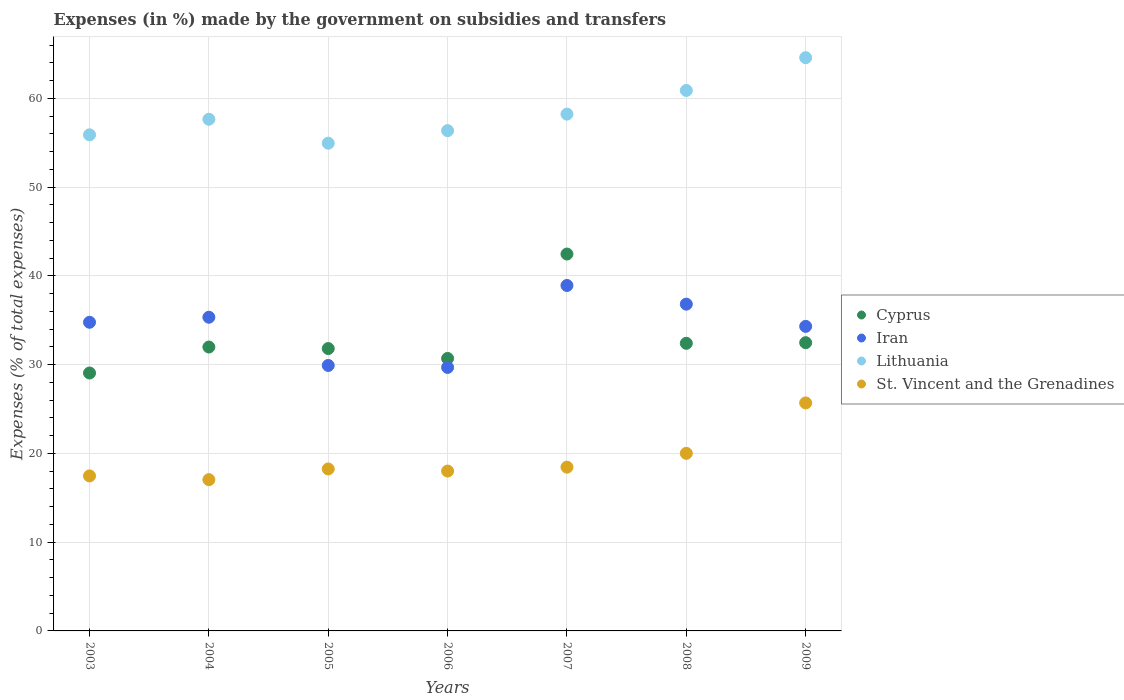What is the percentage of expenses made by the government on subsidies and transfers in Lithuania in 2004?
Your answer should be very brief. 57.65. Across all years, what is the maximum percentage of expenses made by the government on subsidies and transfers in St. Vincent and the Grenadines?
Offer a very short reply. 25.69. Across all years, what is the minimum percentage of expenses made by the government on subsidies and transfers in Lithuania?
Provide a short and direct response. 54.96. In which year was the percentage of expenses made by the government on subsidies and transfers in Lithuania maximum?
Your answer should be very brief. 2009. What is the total percentage of expenses made by the government on subsidies and transfers in St. Vincent and the Grenadines in the graph?
Your answer should be very brief. 134.93. What is the difference between the percentage of expenses made by the government on subsidies and transfers in Iran in 2006 and that in 2008?
Provide a succinct answer. -7.13. What is the difference between the percentage of expenses made by the government on subsidies and transfers in Iran in 2003 and the percentage of expenses made by the government on subsidies and transfers in St. Vincent and the Grenadines in 2009?
Ensure brevity in your answer.  9.09. What is the average percentage of expenses made by the government on subsidies and transfers in Iran per year?
Offer a very short reply. 34.26. In the year 2006, what is the difference between the percentage of expenses made by the government on subsidies and transfers in Iran and percentage of expenses made by the government on subsidies and transfers in St. Vincent and the Grenadines?
Give a very brief answer. 11.68. What is the ratio of the percentage of expenses made by the government on subsidies and transfers in St. Vincent and the Grenadines in 2006 to that in 2009?
Make the answer very short. 0.7. Is the percentage of expenses made by the government on subsidies and transfers in St. Vincent and the Grenadines in 2007 less than that in 2008?
Your answer should be compact. Yes. Is the difference between the percentage of expenses made by the government on subsidies and transfers in Iran in 2004 and 2007 greater than the difference between the percentage of expenses made by the government on subsidies and transfers in St. Vincent and the Grenadines in 2004 and 2007?
Offer a very short reply. No. What is the difference between the highest and the second highest percentage of expenses made by the government on subsidies and transfers in St. Vincent and the Grenadines?
Keep it short and to the point. 5.68. What is the difference between the highest and the lowest percentage of expenses made by the government on subsidies and transfers in Lithuania?
Offer a terse response. 9.64. Is it the case that in every year, the sum of the percentage of expenses made by the government on subsidies and transfers in St. Vincent and the Grenadines and percentage of expenses made by the government on subsidies and transfers in Cyprus  is greater than the sum of percentage of expenses made by the government on subsidies and transfers in Lithuania and percentage of expenses made by the government on subsidies and transfers in Iran?
Offer a very short reply. Yes. Is the percentage of expenses made by the government on subsidies and transfers in Lithuania strictly greater than the percentage of expenses made by the government on subsidies and transfers in Iran over the years?
Your answer should be compact. Yes. Are the values on the major ticks of Y-axis written in scientific E-notation?
Make the answer very short. No. Does the graph contain grids?
Offer a terse response. Yes. How are the legend labels stacked?
Your answer should be very brief. Vertical. What is the title of the graph?
Your answer should be very brief. Expenses (in %) made by the government on subsidies and transfers. What is the label or title of the Y-axis?
Give a very brief answer. Expenses (% of total expenses). What is the Expenses (% of total expenses) of Cyprus in 2003?
Offer a terse response. 29.06. What is the Expenses (% of total expenses) in Iran in 2003?
Offer a terse response. 34.78. What is the Expenses (% of total expenses) of Lithuania in 2003?
Make the answer very short. 55.9. What is the Expenses (% of total expenses) of St. Vincent and the Grenadines in 2003?
Make the answer very short. 17.47. What is the Expenses (% of total expenses) in Cyprus in 2004?
Your response must be concise. 31.99. What is the Expenses (% of total expenses) in Iran in 2004?
Offer a terse response. 35.34. What is the Expenses (% of total expenses) of Lithuania in 2004?
Your response must be concise. 57.65. What is the Expenses (% of total expenses) of St. Vincent and the Grenadines in 2004?
Give a very brief answer. 17.04. What is the Expenses (% of total expenses) in Cyprus in 2005?
Offer a terse response. 31.82. What is the Expenses (% of total expenses) in Iran in 2005?
Your answer should be compact. 29.91. What is the Expenses (% of total expenses) of Lithuania in 2005?
Make the answer very short. 54.96. What is the Expenses (% of total expenses) in St. Vincent and the Grenadines in 2005?
Your response must be concise. 18.25. What is the Expenses (% of total expenses) of Cyprus in 2006?
Provide a short and direct response. 30.7. What is the Expenses (% of total expenses) in Iran in 2006?
Provide a short and direct response. 29.69. What is the Expenses (% of total expenses) of Lithuania in 2006?
Offer a very short reply. 56.37. What is the Expenses (% of total expenses) in St. Vincent and the Grenadines in 2006?
Your answer should be compact. 18.01. What is the Expenses (% of total expenses) of Cyprus in 2007?
Offer a very short reply. 42.47. What is the Expenses (% of total expenses) in Iran in 2007?
Your answer should be very brief. 38.93. What is the Expenses (% of total expenses) of Lithuania in 2007?
Your response must be concise. 58.23. What is the Expenses (% of total expenses) of St. Vincent and the Grenadines in 2007?
Offer a very short reply. 18.45. What is the Expenses (% of total expenses) of Cyprus in 2008?
Ensure brevity in your answer.  32.41. What is the Expenses (% of total expenses) of Iran in 2008?
Provide a succinct answer. 36.82. What is the Expenses (% of total expenses) of Lithuania in 2008?
Ensure brevity in your answer.  60.9. What is the Expenses (% of total expenses) of St. Vincent and the Grenadines in 2008?
Provide a short and direct response. 20.01. What is the Expenses (% of total expenses) in Cyprus in 2009?
Offer a terse response. 32.48. What is the Expenses (% of total expenses) in Iran in 2009?
Your answer should be compact. 34.32. What is the Expenses (% of total expenses) in Lithuania in 2009?
Provide a succinct answer. 64.59. What is the Expenses (% of total expenses) of St. Vincent and the Grenadines in 2009?
Your answer should be compact. 25.69. Across all years, what is the maximum Expenses (% of total expenses) in Cyprus?
Give a very brief answer. 42.47. Across all years, what is the maximum Expenses (% of total expenses) in Iran?
Keep it short and to the point. 38.93. Across all years, what is the maximum Expenses (% of total expenses) in Lithuania?
Provide a short and direct response. 64.59. Across all years, what is the maximum Expenses (% of total expenses) of St. Vincent and the Grenadines?
Ensure brevity in your answer.  25.69. Across all years, what is the minimum Expenses (% of total expenses) of Cyprus?
Your answer should be compact. 29.06. Across all years, what is the minimum Expenses (% of total expenses) in Iran?
Provide a short and direct response. 29.69. Across all years, what is the minimum Expenses (% of total expenses) in Lithuania?
Your response must be concise. 54.96. Across all years, what is the minimum Expenses (% of total expenses) of St. Vincent and the Grenadines?
Your answer should be very brief. 17.04. What is the total Expenses (% of total expenses) of Cyprus in the graph?
Provide a succinct answer. 230.93. What is the total Expenses (% of total expenses) of Iran in the graph?
Ensure brevity in your answer.  239.79. What is the total Expenses (% of total expenses) in Lithuania in the graph?
Make the answer very short. 408.61. What is the total Expenses (% of total expenses) of St. Vincent and the Grenadines in the graph?
Make the answer very short. 134.93. What is the difference between the Expenses (% of total expenses) of Cyprus in 2003 and that in 2004?
Keep it short and to the point. -2.93. What is the difference between the Expenses (% of total expenses) in Iran in 2003 and that in 2004?
Offer a very short reply. -0.57. What is the difference between the Expenses (% of total expenses) of Lithuania in 2003 and that in 2004?
Offer a terse response. -1.75. What is the difference between the Expenses (% of total expenses) in St. Vincent and the Grenadines in 2003 and that in 2004?
Ensure brevity in your answer.  0.43. What is the difference between the Expenses (% of total expenses) of Cyprus in 2003 and that in 2005?
Offer a terse response. -2.75. What is the difference between the Expenses (% of total expenses) of Iran in 2003 and that in 2005?
Your answer should be compact. 4.87. What is the difference between the Expenses (% of total expenses) in Lithuania in 2003 and that in 2005?
Provide a succinct answer. 0.94. What is the difference between the Expenses (% of total expenses) in St. Vincent and the Grenadines in 2003 and that in 2005?
Your response must be concise. -0.78. What is the difference between the Expenses (% of total expenses) in Cyprus in 2003 and that in 2006?
Make the answer very short. -1.64. What is the difference between the Expenses (% of total expenses) of Iran in 2003 and that in 2006?
Offer a terse response. 5.09. What is the difference between the Expenses (% of total expenses) in Lithuania in 2003 and that in 2006?
Give a very brief answer. -0.47. What is the difference between the Expenses (% of total expenses) of St. Vincent and the Grenadines in 2003 and that in 2006?
Offer a terse response. -0.55. What is the difference between the Expenses (% of total expenses) in Cyprus in 2003 and that in 2007?
Your answer should be compact. -13.41. What is the difference between the Expenses (% of total expenses) of Iran in 2003 and that in 2007?
Offer a terse response. -4.15. What is the difference between the Expenses (% of total expenses) of Lithuania in 2003 and that in 2007?
Ensure brevity in your answer.  -2.33. What is the difference between the Expenses (% of total expenses) in St. Vincent and the Grenadines in 2003 and that in 2007?
Offer a terse response. -0.99. What is the difference between the Expenses (% of total expenses) of Cyprus in 2003 and that in 2008?
Make the answer very short. -3.35. What is the difference between the Expenses (% of total expenses) of Iran in 2003 and that in 2008?
Provide a succinct answer. -2.04. What is the difference between the Expenses (% of total expenses) in Lithuania in 2003 and that in 2008?
Your answer should be compact. -5. What is the difference between the Expenses (% of total expenses) in St. Vincent and the Grenadines in 2003 and that in 2008?
Keep it short and to the point. -2.54. What is the difference between the Expenses (% of total expenses) of Cyprus in 2003 and that in 2009?
Your answer should be compact. -3.42. What is the difference between the Expenses (% of total expenses) of Iran in 2003 and that in 2009?
Provide a succinct answer. 0.46. What is the difference between the Expenses (% of total expenses) in Lithuania in 2003 and that in 2009?
Your answer should be compact. -8.69. What is the difference between the Expenses (% of total expenses) in St. Vincent and the Grenadines in 2003 and that in 2009?
Your answer should be compact. -8.22. What is the difference between the Expenses (% of total expenses) in Cyprus in 2004 and that in 2005?
Give a very brief answer. 0.17. What is the difference between the Expenses (% of total expenses) in Iran in 2004 and that in 2005?
Offer a very short reply. 5.43. What is the difference between the Expenses (% of total expenses) of Lithuania in 2004 and that in 2005?
Offer a terse response. 2.7. What is the difference between the Expenses (% of total expenses) in St. Vincent and the Grenadines in 2004 and that in 2005?
Offer a terse response. -1.21. What is the difference between the Expenses (% of total expenses) of Cyprus in 2004 and that in 2006?
Keep it short and to the point. 1.29. What is the difference between the Expenses (% of total expenses) in Iran in 2004 and that in 2006?
Ensure brevity in your answer.  5.65. What is the difference between the Expenses (% of total expenses) of Lithuania in 2004 and that in 2006?
Your answer should be very brief. 1.28. What is the difference between the Expenses (% of total expenses) in St. Vincent and the Grenadines in 2004 and that in 2006?
Provide a succinct answer. -0.97. What is the difference between the Expenses (% of total expenses) in Cyprus in 2004 and that in 2007?
Provide a succinct answer. -10.48. What is the difference between the Expenses (% of total expenses) in Iran in 2004 and that in 2007?
Keep it short and to the point. -3.58. What is the difference between the Expenses (% of total expenses) in Lithuania in 2004 and that in 2007?
Offer a very short reply. -0.58. What is the difference between the Expenses (% of total expenses) in St. Vincent and the Grenadines in 2004 and that in 2007?
Offer a terse response. -1.41. What is the difference between the Expenses (% of total expenses) of Cyprus in 2004 and that in 2008?
Offer a very short reply. -0.42. What is the difference between the Expenses (% of total expenses) of Iran in 2004 and that in 2008?
Give a very brief answer. -1.48. What is the difference between the Expenses (% of total expenses) of Lithuania in 2004 and that in 2008?
Offer a very short reply. -3.25. What is the difference between the Expenses (% of total expenses) of St. Vincent and the Grenadines in 2004 and that in 2008?
Offer a terse response. -2.97. What is the difference between the Expenses (% of total expenses) in Cyprus in 2004 and that in 2009?
Keep it short and to the point. -0.49. What is the difference between the Expenses (% of total expenses) of Iran in 2004 and that in 2009?
Offer a terse response. 1.03. What is the difference between the Expenses (% of total expenses) of Lithuania in 2004 and that in 2009?
Offer a terse response. -6.94. What is the difference between the Expenses (% of total expenses) in St. Vincent and the Grenadines in 2004 and that in 2009?
Your answer should be very brief. -8.65. What is the difference between the Expenses (% of total expenses) of Cyprus in 2005 and that in 2006?
Ensure brevity in your answer.  1.11. What is the difference between the Expenses (% of total expenses) in Iran in 2005 and that in 2006?
Provide a short and direct response. 0.22. What is the difference between the Expenses (% of total expenses) in Lithuania in 2005 and that in 2006?
Provide a succinct answer. -1.42. What is the difference between the Expenses (% of total expenses) of St. Vincent and the Grenadines in 2005 and that in 2006?
Your answer should be very brief. 0.24. What is the difference between the Expenses (% of total expenses) in Cyprus in 2005 and that in 2007?
Provide a succinct answer. -10.65. What is the difference between the Expenses (% of total expenses) in Iran in 2005 and that in 2007?
Make the answer very short. -9.01. What is the difference between the Expenses (% of total expenses) in Lithuania in 2005 and that in 2007?
Give a very brief answer. -3.28. What is the difference between the Expenses (% of total expenses) of St. Vincent and the Grenadines in 2005 and that in 2007?
Your answer should be very brief. -0.2. What is the difference between the Expenses (% of total expenses) of Cyprus in 2005 and that in 2008?
Offer a terse response. -0.59. What is the difference between the Expenses (% of total expenses) of Iran in 2005 and that in 2008?
Provide a succinct answer. -6.91. What is the difference between the Expenses (% of total expenses) in Lithuania in 2005 and that in 2008?
Your answer should be compact. -5.94. What is the difference between the Expenses (% of total expenses) in St. Vincent and the Grenadines in 2005 and that in 2008?
Give a very brief answer. -1.76. What is the difference between the Expenses (% of total expenses) of Cyprus in 2005 and that in 2009?
Offer a very short reply. -0.66. What is the difference between the Expenses (% of total expenses) in Iran in 2005 and that in 2009?
Your response must be concise. -4.4. What is the difference between the Expenses (% of total expenses) of Lithuania in 2005 and that in 2009?
Provide a short and direct response. -9.64. What is the difference between the Expenses (% of total expenses) of St. Vincent and the Grenadines in 2005 and that in 2009?
Provide a short and direct response. -7.44. What is the difference between the Expenses (% of total expenses) in Cyprus in 2006 and that in 2007?
Ensure brevity in your answer.  -11.76. What is the difference between the Expenses (% of total expenses) in Iran in 2006 and that in 2007?
Offer a very short reply. -9.23. What is the difference between the Expenses (% of total expenses) of Lithuania in 2006 and that in 2007?
Your answer should be very brief. -1.86. What is the difference between the Expenses (% of total expenses) in St. Vincent and the Grenadines in 2006 and that in 2007?
Your response must be concise. -0.44. What is the difference between the Expenses (% of total expenses) of Cyprus in 2006 and that in 2008?
Your answer should be very brief. -1.7. What is the difference between the Expenses (% of total expenses) in Iran in 2006 and that in 2008?
Your answer should be very brief. -7.13. What is the difference between the Expenses (% of total expenses) in Lithuania in 2006 and that in 2008?
Offer a very short reply. -4.53. What is the difference between the Expenses (% of total expenses) of St. Vincent and the Grenadines in 2006 and that in 2008?
Your answer should be compact. -2. What is the difference between the Expenses (% of total expenses) of Cyprus in 2006 and that in 2009?
Provide a short and direct response. -1.78. What is the difference between the Expenses (% of total expenses) of Iran in 2006 and that in 2009?
Give a very brief answer. -4.62. What is the difference between the Expenses (% of total expenses) in Lithuania in 2006 and that in 2009?
Provide a succinct answer. -8.22. What is the difference between the Expenses (% of total expenses) of St. Vincent and the Grenadines in 2006 and that in 2009?
Provide a succinct answer. -7.68. What is the difference between the Expenses (% of total expenses) of Cyprus in 2007 and that in 2008?
Your answer should be compact. 10.06. What is the difference between the Expenses (% of total expenses) in Iran in 2007 and that in 2008?
Provide a short and direct response. 2.1. What is the difference between the Expenses (% of total expenses) of Lithuania in 2007 and that in 2008?
Give a very brief answer. -2.67. What is the difference between the Expenses (% of total expenses) of St. Vincent and the Grenadines in 2007 and that in 2008?
Your answer should be very brief. -1.56. What is the difference between the Expenses (% of total expenses) in Cyprus in 2007 and that in 2009?
Your response must be concise. 9.99. What is the difference between the Expenses (% of total expenses) in Iran in 2007 and that in 2009?
Make the answer very short. 4.61. What is the difference between the Expenses (% of total expenses) in Lithuania in 2007 and that in 2009?
Your answer should be very brief. -6.36. What is the difference between the Expenses (% of total expenses) in St. Vincent and the Grenadines in 2007 and that in 2009?
Your answer should be very brief. -7.24. What is the difference between the Expenses (% of total expenses) in Cyprus in 2008 and that in 2009?
Your answer should be compact. -0.07. What is the difference between the Expenses (% of total expenses) of Iran in 2008 and that in 2009?
Give a very brief answer. 2.5. What is the difference between the Expenses (% of total expenses) of Lithuania in 2008 and that in 2009?
Provide a short and direct response. -3.69. What is the difference between the Expenses (% of total expenses) in St. Vincent and the Grenadines in 2008 and that in 2009?
Your answer should be compact. -5.68. What is the difference between the Expenses (% of total expenses) of Cyprus in 2003 and the Expenses (% of total expenses) of Iran in 2004?
Provide a short and direct response. -6.28. What is the difference between the Expenses (% of total expenses) of Cyprus in 2003 and the Expenses (% of total expenses) of Lithuania in 2004?
Your answer should be compact. -28.59. What is the difference between the Expenses (% of total expenses) of Cyprus in 2003 and the Expenses (% of total expenses) of St. Vincent and the Grenadines in 2004?
Ensure brevity in your answer.  12.02. What is the difference between the Expenses (% of total expenses) in Iran in 2003 and the Expenses (% of total expenses) in Lithuania in 2004?
Provide a succinct answer. -22.88. What is the difference between the Expenses (% of total expenses) in Iran in 2003 and the Expenses (% of total expenses) in St. Vincent and the Grenadines in 2004?
Your answer should be compact. 17.74. What is the difference between the Expenses (% of total expenses) in Lithuania in 2003 and the Expenses (% of total expenses) in St. Vincent and the Grenadines in 2004?
Ensure brevity in your answer.  38.86. What is the difference between the Expenses (% of total expenses) in Cyprus in 2003 and the Expenses (% of total expenses) in Iran in 2005?
Offer a terse response. -0.85. What is the difference between the Expenses (% of total expenses) of Cyprus in 2003 and the Expenses (% of total expenses) of Lithuania in 2005?
Ensure brevity in your answer.  -25.89. What is the difference between the Expenses (% of total expenses) in Cyprus in 2003 and the Expenses (% of total expenses) in St. Vincent and the Grenadines in 2005?
Ensure brevity in your answer.  10.81. What is the difference between the Expenses (% of total expenses) of Iran in 2003 and the Expenses (% of total expenses) of Lithuania in 2005?
Offer a terse response. -20.18. What is the difference between the Expenses (% of total expenses) of Iran in 2003 and the Expenses (% of total expenses) of St. Vincent and the Grenadines in 2005?
Your response must be concise. 16.53. What is the difference between the Expenses (% of total expenses) in Lithuania in 2003 and the Expenses (% of total expenses) in St. Vincent and the Grenadines in 2005?
Offer a terse response. 37.65. What is the difference between the Expenses (% of total expenses) in Cyprus in 2003 and the Expenses (% of total expenses) in Iran in 2006?
Offer a very short reply. -0.63. What is the difference between the Expenses (% of total expenses) of Cyprus in 2003 and the Expenses (% of total expenses) of Lithuania in 2006?
Make the answer very short. -27.31. What is the difference between the Expenses (% of total expenses) in Cyprus in 2003 and the Expenses (% of total expenses) in St. Vincent and the Grenadines in 2006?
Make the answer very short. 11.05. What is the difference between the Expenses (% of total expenses) in Iran in 2003 and the Expenses (% of total expenses) in Lithuania in 2006?
Ensure brevity in your answer.  -21.59. What is the difference between the Expenses (% of total expenses) in Iran in 2003 and the Expenses (% of total expenses) in St. Vincent and the Grenadines in 2006?
Give a very brief answer. 16.76. What is the difference between the Expenses (% of total expenses) of Lithuania in 2003 and the Expenses (% of total expenses) of St. Vincent and the Grenadines in 2006?
Offer a very short reply. 37.89. What is the difference between the Expenses (% of total expenses) in Cyprus in 2003 and the Expenses (% of total expenses) in Iran in 2007?
Provide a short and direct response. -9.86. What is the difference between the Expenses (% of total expenses) in Cyprus in 2003 and the Expenses (% of total expenses) in Lithuania in 2007?
Your answer should be compact. -29.17. What is the difference between the Expenses (% of total expenses) of Cyprus in 2003 and the Expenses (% of total expenses) of St. Vincent and the Grenadines in 2007?
Your answer should be compact. 10.61. What is the difference between the Expenses (% of total expenses) of Iran in 2003 and the Expenses (% of total expenses) of Lithuania in 2007?
Provide a succinct answer. -23.46. What is the difference between the Expenses (% of total expenses) of Iran in 2003 and the Expenses (% of total expenses) of St. Vincent and the Grenadines in 2007?
Keep it short and to the point. 16.33. What is the difference between the Expenses (% of total expenses) of Lithuania in 2003 and the Expenses (% of total expenses) of St. Vincent and the Grenadines in 2007?
Your answer should be compact. 37.45. What is the difference between the Expenses (% of total expenses) in Cyprus in 2003 and the Expenses (% of total expenses) in Iran in 2008?
Keep it short and to the point. -7.76. What is the difference between the Expenses (% of total expenses) of Cyprus in 2003 and the Expenses (% of total expenses) of Lithuania in 2008?
Offer a very short reply. -31.84. What is the difference between the Expenses (% of total expenses) in Cyprus in 2003 and the Expenses (% of total expenses) in St. Vincent and the Grenadines in 2008?
Ensure brevity in your answer.  9.05. What is the difference between the Expenses (% of total expenses) in Iran in 2003 and the Expenses (% of total expenses) in Lithuania in 2008?
Offer a terse response. -26.12. What is the difference between the Expenses (% of total expenses) of Iran in 2003 and the Expenses (% of total expenses) of St. Vincent and the Grenadines in 2008?
Give a very brief answer. 14.77. What is the difference between the Expenses (% of total expenses) in Lithuania in 2003 and the Expenses (% of total expenses) in St. Vincent and the Grenadines in 2008?
Your response must be concise. 35.89. What is the difference between the Expenses (% of total expenses) in Cyprus in 2003 and the Expenses (% of total expenses) in Iran in 2009?
Offer a terse response. -5.25. What is the difference between the Expenses (% of total expenses) in Cyprus in 2003 and the Expenses (% of total expenses) in Lithuania in 2009?
Ensure brevity in your answer.  -35.53. What is the difference between the Expenses (% of total expenses) in Cyprus in 2003 and the Expenses (% of total expenses) in St. Vincent and the Grenadines in 2009?
Give a very brief answer. 3.37. What is the difference between the Expenses (% of total expenses) in Iran in 2003 and the Expenses (% of total expenses) in Lithuania in 2009?
Your response must be concise. -29.82. What is the difference between the Expenses (% of total expenses) in Iran in 2003 and the Expenses (% of total expenses) in St. Vincent and the Grenadines in 2009?
Your response must be concise. 9.09. What is the difference between the Expenses (% of total expenses) of Lithuania in 2003 and the Expenses (% of total expenses) of St. Vincent and the Grenadines in 2009?
Your response must be concise. 30.21. What is the difference between the Expenses (% of total expenses) of Cyprus in 2004 and the Expenses (% of total expenses) of Iran in 2005?
Offer a very short reply. 2.08. What is the difference between the Expenses (% of total expenses) in Cyprus in 2004 and the Expenses (% of total expenses) in Lithuania in 2005?
Your answer should be compact. -22.97. What is the difference between the Expenses (% of total expenses) of Cyprus in 2004 and the Expenses (% of total expenses) of St. Vincent and the Grenadines in 2005?
Offer a terse response. 13.74. What is the difference between the Expenses (% of total expenses) in Iran in 2004 and the Expenses (% of total expenses) in Lithuania in 2005?
Your response must be concise. -19.61. What is the difference between the Expenses (% of total expenses) of Iran in 2004 and the Expenses (% of total expenses) of St. Vincent and the Grenadines in 2005?
Your response must be concise. 17.09. What is the difference between the Expenses (% of total expenses) in Lithuania in 2004 and the Expenses (% of total expenses) in St. Vincent and the Grenadines in 2005?
Give a very brief answer. 39.4. What is the difference between the Expenses (% of total expenses) in Cyprus in 2004 and the Expenses (% of total expenses) in Iran in 2006?
Offer a terse response. 2.3. What is the difference between the Expenses (% of total expenses) in Cyprus in 2004 and the Expenses (% of total expenses) in Lithuania in 2006?
Make the answer very short. -24.38. What is the difference between the Expenses (% of total expenses) in Cyprus in 2004 and the Expenses (% of total expenses) in St. Vincent and the Grenadines in 2006?
Provide a succinct answer. 13.98. What is the difference between the Expenses (% of total expenses) of Iran in 2004 and the Expenses (% of total expenses) of Lithuania in 2006?
Your response must be concise. -21.03. What is the difference between the Expenses (% of total expenses) in Iran in 2004 and the Expenses (% of total expenses) in St. Vincent and the Grenadines in 2006?
Your answer should be compact. 17.33. What is the difference between the Expenses (% of total expenses) of Lithuania in 2004 and the Expenses (% of total expenses) of St. Vincent and the Grenadines in 2006?
Offer a terse response. 39.64. What is the difference between the Expenses (% of total expenses) in Cyprus in 2004 and the Expenses (% of total expenses) in Iran in 2007?
Provide a short and direct response. -6.94. What is the difference between the Expenses (% of total expenses) in Cyprus in 2004 and the Expenses (% of total expenses) in Lithuania in 2007?
Your answer should be very brief. -26.24. What is the difference between the Expenses (% of total expenses) of Cyprus in 2004 and the Expenses (% of total expenses) of St. Vincent and the Grenadines in 2007?
Ensure brevity in your answer.  13.54. What is the difference between the Expenses (% of total expenses) of Iran in 2004 and the Expenses (% of total expenses) of Lithuania in 2007?
Ensure brevity in your answer.  -22.89. What is the difference between the Expenses (% of total expenses) in Iran in 2004 and the Expenses (% of total expenses) in St. Vincent and the Grenadines in 2007?
Make the answer very short. 16.89. What is the difference between the Expenses (% of total expenses) of Lithuania in 2004 and the Expenses (% of total expenses) of St. Vincent and the Grenadines in 2007?
Offer a very short reply. 39.2. What is the difference between the Expenses (% of total expenses) in Cyprus in 2004 and the Expenses (% of total expenses) in Iran in 2008?
Offer a very short reply. -4.83. What is the difference between the Expenses (% of total expenses) in Cyprus in 2004 and the Expenses (% of total expenses) in Lithuania in 2008?
Ensure brevity in your answer.  -28.91. What is the difference between the Expenses (% of total expenses) of Cyprus in 2004 and the Expenses (% of total expenses) of St. Vincent and the Grenadines in 2008?
Your answer should be very brief. 11.98. What is the difference between the Expenses (% of total expenses) in Iran in 2004 and the Expenses (% of total expenses) in Lithuania in 2008?
Your response must be concise. -25.55. What is the difference between the Expenses (% of total expenses) in Iran in 2004 and the Expenses (% of total expenses) in St. Vincent and the Grenadines in 2008?
Give a very brief answer. 15.34. What is the difference between the Expenses (% of total expenses) of Lithuania in 2004 and the Expenses (% of total expenses) of St. Vincent and the Grenadines in 2008?
Provide a short and direct response. 37.65. What is the difference between the Expenses (% of total expenses) in Cyprus in 2004 and the Expenses (% of total expenses) in Iran in 2009?
Provide a succinct answer. -2.33. What is the difference between the Expenses (% of total expenses) in Cyprus in 2004 and the Expenses (% of total expenses) in Lithuania in 2009?
Offer a very short reply. -32.6. What is the difference between the Expenses (% of total expenses) of Cyprus in 2004 and the Expenses (% of total expenses) of St. Vincent and the Grenadines in 2009?
Make the answer very short. 6.3. What is the difference between the Expenses (% of total expenses) in Iran in 2004 and the Expenses (% of total expenses) in Lithuania in 2009?
Offer a very short reply. -29.25. What is the difference between the Expenses (% of total expenses) of Iran in 2004 and the Expenses (% of total expenses) of St. Vincent and the Grenadines in 2009?
Ensure brevity in your answer.  9.65. What is the difference between the Expenses (% of total expenses) of Lithuania in 2004 and the Expenses (% of total expenses) of St. Vincent and the Grenadines in 2009?
Offer a very short reply. 31.96. What is the difference between the Expenses (% of total expenses) of Cyprus in 2005 and the Expenses (% of total expenses) of Iran in 2006?
Provide a short and direct response. 2.12. What is the difference between the Expenses (% of total expenses) of Cyprus in 2005 and the Expenses (% of total expenses) of Lithuania in 2006?
Your response must be concise. -24.55. What is the difference between the Expenses (% of total expenses) in Cyprus in 2005 and the Expenses (% of total expenses) in St. Vincent and the Grenadines in 2006?
Keep it short and to the point. 13.8. What is the difference between the Expenses (% of total expenses) in Iran in 2005 and the Expenses (% of total expenses) in Lithuania in 2006?
Offer a very short reply. -26.46. What is the difference between the Expenses (% of total expenses) of Iran in 2005 and the Expenses (% of total expenses) of St. Vincent and the Grenadines in 2006?
Provide a succinct answer. 11.9. What is the difference between the Expenses (% of total expenses) in Lithuania in 2005 and the Expenses (% of total expenses) in St. Vincent and the Grenadines in 2006?
Give a very brief answer. 36.94. What is the difference between the Expenses (% of total expenses) of Cyprus in 2005 and the Expenses (% of total expenses) of Iran in 2007?
Offer a very short reply. -7.11. What is the difference between the Expenses (% of total expenses) in Cyprus in 2005 and the Expenses (% of total expenses) in Lithuania in 2007?
Provide a short and direct response. -26.42. What is the difference between the Expenses (% of total expenses) of Cyprus in 2005 and the Expenses (% of total expenses) of St. Vincent and the Grenadines in 2007?
Make the answer very short. 13.36. What is the difference between the Expenses (% of total expenses) in Iran in 2005 and the Expenses (% of total expenses) in Lithuania in 2007?
Provide a succinct answer. -28.32. What is the difference between the Expenses (% of total expenses) in Iran in 2005 and the Expenses (% of total expenses) in St. Vincent and the Grenadines in 2007?
Your response must be concise. 11.46. What is the difference between the Expenses (% of total expenses) in Lithuania in 2005 and the Expenses (% of total expenses) in St. Vincent and the Grenadines in 2007?
Offer a very short reply. 36.5. What is the difference between the Expenses (% of total expenses) of Cyprus in 2005 and the Expenses (% of total expenses) of Iran in 2008?
Your answer should be compact. -5. What is the difference between the Expenses (% of total expenses) of Cyprus in 2005 and the Expenses (% of total expenses) of Lithuania in 2008?
Offer a very short reply. -29.08. What is the difference between the Expenses (% of total expenses) in Cyprus in 2005 and the Expenses (% of total expenses) in St. Vincent and the Grenadines in 2008?
Make the answer very short. 11.81. What is the difference between the Expenses (% of total expenses) in Iran in 2005 and the Expenses (% of total expenses) in Lithuania in 2008?
Offer a very short reply. -30.99. What is the difference between the Expenses (% of total expenses) of Iran in 2005 and the Expenses (% of total expenses) of St. Vincent and the Grenadines in 2008?
Your answer should be very brief. 9.9. What is the difference between the Expenses (% of total expenses) in Lithuania in 2005 and the Expenses (% of total expenses) in St. Vincent and the Grenadines in 2008?
Your answer should be compact. 34.95. What is the difference between the Expenses (% of total expenses) of Cyprus in 2005 and the Expenses (% of total expenses) of Iran in 2009?
Provide a short and direct response. -2.5. What is the difference between the Expenses (% of total expenses) in Cyprus in 2005 and the Expenses (% of total expenses) in Lithuania in 2009?
Provide a succinct answer. -32.78. What is the difference between the Expenses (% of total expenses) in Cyprus in 2005 and the Expenses (% of total expenses) in St. Vincent and the Grenadines in 2009?
Make the answer very short. 6.13. What is the difference between the Expenses (% of total expenses) in Iran in 2005 and the Expenses (% of total expenses) in Lithuania in 2009?
Provide a succinct answer. -34.68. What is the difference between the Expenses (% of total expenses) in Iran in 2005 and the Expenses (% of total expenses) in St. Vincent and the Grenadines in 2009?
Provide a short and direct response. 4.22. What is the difference between the Expenses (% of total expenses) of Lithuania in 2005 and the Expenses (% of total expenses) of St. Vincent and the Grenadines in 2009?
Make the answer very short. 29.26. What is the difference between the Expenses (% of total expenses) in Cyprus in 2006 and the Expenses (% of total expenses) in Iran in 2007?
Provide a short and direct response. -8.22. What is the difference between the Expenses (% of total expenses) in Cyprus in 2006 and the Expenses (% of total expenses) in Lithuania in 2007?
Your response must be concise. -27.53. What is the difference between the Expenses (% of total expenses) of Cyprus in 2006 and the Expenses (% of total expenses) of St. Vincent and the Grenadines in 2007?
Give a very brief answer. 12.25. What is the difference between the Expenses (% of total expenses) of Iran in 2006 and the Expenses (% of total expenses) of Lithuania in 2007?
Ensure brevity in your answer.  -28.54. What is the difference between the Expenses (% of total expenses) of Iran in 2006 and the Expenses (% of total expenses) of St. Vincent and the Grenadines in 2007?
Provide a succinct answer. 11.24. What is the difference between the Expenses (% of total expenses) of Lithuania in 2006 and the Expenses (% of total expenses) of St. Vincent and the Grenadines in 2007?
Your response must be concise. 37.92. What is the difference between the Expenses (% of total expenses) of Cyprus in 2006 and the Expenses (% of total expenses) of Iran in 2008?
Keep it short and to the point. -6.12. What is the difference between the Expenses (% of total expenses) of Cyprus in 2006 and the Expenses (% of total expenses) of Lithuania in 2008?
Your response must be concise. -30.2. What is the difference between the Expenses (% of total expenses) of Cyprus in 2006 and the Expenses (% of total expenses) of St. Vincent and the Grenadines in 2008?
Keep it short and to the point. 10.7. What is the difference between the Expenses (% of total expenses) of Iran in 2006 and the Expenses (% of total expenses) of Lithuania in 2008?
Provide a short and direct response. -31.21. What is the difference between the Expenses (% of total expenses) of Iran in 2006 and the Expenses (% of total expenses) of St. Vincent and the Grenadines in 2008?
Make the answer very short. 9.68. What is the difference between the Expenses (% of total expenses) in Lithuania in 2006 and the Expenses (% of total expenses) in St. Vincent and the Grenadines in 2008?
Offer a terse response. 36.36. What is the difference between the Expenses (% of total expenses) in Cyprus in 2006 and the Expenses (% of total expenses) in Iran in 2009?
Offer a terse response. -3.61. What is the difference between the Expenses (% of total expenses) in Cyprus in 2006 and the Expenses (% of total expenses) in Lithuania in 2009?
Your answer should be compact. -33.89. What is the difference between the Expenses (% of total expenses) of Cyprus in 2006 and the Expenses (% of total expenses) of St. Vincent and the Grenadines in 2009?
Make the answer very short. 5.01. What is the difference between the Expenses (% of total expenses) in Iran in 2006 and the Expenses (% of total expenses) in Lithuania in 2009?
Offer a very short reply. -34.9. What is the difference between the Expenses (% of total expenses) of Iran in 2006 and the Expenses (% of total expenses) of St. Vincent and the Grenadines in 2009?
Offer a very short reply. 4. What is the difference between the Expenses (% of total expenses) in Lithuania in 2006 and the Expenses (% of total expenses) in St. Vincent and the Grenadines in 2009?
Your answer should be very brief. 30.68. What is the difference between the Expenses (% of total expenses) in Cyprus in 2007 and the Expenses (% of total expenses) in Iran in 2008?
Give a very brief answer. 5.65. What is the difference between the Expenses (% of total expenses) in Cyprus in 2007 and the Expenses (% of total expenses) in Lithuania in 2008?
Provide a short and direct response. -18.43. What is the difference between the Expenses (% of total expenses) in Cyprus in 2007 and the Expenses (% of total expenses) in St. Vincent and the Grenadines in 2008?
Give a very brief answer. 22.46. What is the difference between the Expenses (% of total expenses) of Iran in 2007 and the Expenses (% of total expenses) of Lithuania in 2008?
Make the answer very short. -21.97. What is the difference between the Expenses (% of total expenses) of Iran in 2007 and the Expenses (% of total expenses) of St. Vincent and the Grenadines in 2008?
Provide a succinct answer. 18.92. What is the difference between the Expenses (% of total expenses) of Lithuania in 2007 and the Expenses (% of total expenses) of St. Vincent and the Grenadines in 2008?
Give a very brief answer. 38.22. What is the difference between the Expenses (% of total expenses) of Cyprus in 2007 and the Expenses (% of total expenses) of Iran in 2009?
Offer a terse response. 8.15. What is the difference between the Expenses (% of total expenses) of Cyprus in 2007 and the Expenses (% of total expenses) of Lithuania in 2009?
Ensure brevity in your answer.  -22.13. What is the difference between the Expenses (% of total expenses) of Cyprus in 2007 and the Expenses (% of total expenses) of St. Vincent and the Grenadines in 2009?
Offer a very short reply. 16.78. What is the difference between the Expenses (% of total expenses) of Iran in 2007 and the Expenses (% of total expenses) of Lithuania in 2009?
Provide a succinct answer. -25.67. What is the difference between the Expenses (% of total expenses) in Iran in 2007 and the Expenses (% of total expenses) in St. Vincent and the Grenadines in 2009?
Your response must be concise. 13.23. What is the difference between the Expenses (% of total expenses) of Lithuania in 2007 and the Expenses (% of total expenses) of St. Vincent and the Grenadines in 2009?
Give a very brief answer. 32.54. What is the difference between the Expenses (% of total expenses) in Cyprus in 2008 and the Expenses (% of total expenses) in Iran in 2009?
Your response must be concise. -1.91. What is the difference between the Expenses (% of total expenses) of Cyprus in 2008 and the Expenses (% of total expenses) of Lithuania in 2009?
Offer a very short reply. -32.19. What is the difference between the Expenses (% of total expenses) in Cyprus in 2008 and the Expenses (% of total expenses) in St. Vincent and the Grenadines in 2009?
Make the answer very short. 6.72. What is the difference between the Expenses (% of total expenses) of Iran in 2008 and the Expenses (% of total expenses) of Lithuania in 2009?
Provide a succinct answer. -27.77. What is the difference between the Expenses (% of total expenses) of Iran in 2008 and the Expenses (% of total expenses) of St. Vincent and the Grenadines in 2009?
Provide a short and direct response. 11.13. What is the difference between the Expenses (% of total expenses) in Lithuania in 2008 and the Expenses (% of total expenses) in St. Vincent and the Grenadines in 2009?
Ensure brevity in your answer.  35.21. What is the average Expenses (% of total expenses) of Cyprus per year?
Offer a terse response. 32.99. What is the average Expenses (% of total expenses) in Iran per year?
Offer a very short reply. 34.26. What is the average Expenses (% of total expenses) of Lithuania per year?
Ensure brevity in your answer.  58.37. What is the average Expenses (% of total expenses) in St. Vincent and the Grenadines per year?
Keep it short and to the point. 19.28. In the year 2003, what is the difference between the Expenses (% of total expenses) in Cyprus and Expenses (% of total expenses) in Iran?
Keep it short and to the point. -5.72. In the year 2003, what is the difference between the Expenses (% of total expenses) in Cyprus and Expenses (% of total expenses) in Lithuania?
Your answer should be very brief. -26.84. In the year 2003, what is the difference between the Expenses (% of total expenses) of Cyprus and Expenses (% of total expenses) of St. Vincent and the Grenadines?
Your answer should be very brief. 11.59. In the year 2003, what is the difference between the Expenses (% of total expenses) of Iran and Expenses (% of total expenses) of Lithuania?
Give a very brief answer. -21.12. In the year 2003, what is the difference between the Expenses (% of total expenses) of Iran and Expenses (% of total expenses) of St. Vincent and the Grenadines?
Your answer should be compact. 17.31. In the year 2003, what is the difference between the Expenses (% of total expenses) of Lithuania and Expenses (% of total expenses) of St. Vincent and the Grenadines?
Provide a short and direct response. 38.43. In the year 2004, what is the difference between the Expenses (% of total expenses) of Cyprus and Expenses (% of total expenses) of Iran?
Make the answer very short. -3.35. In the year 2004, what is the difference between the Expenses (% of total expenses) in Cyprus and Expenses (% of total expenses) in Lithuania?
Your answer should be compact. -25.66. In the year 2004, what is the difference between the Expenses (% of total expenses) in Cyprus and Expenses (% of total expenses) in St. Vincent and the Grenadines?
Give a very brief answer. 14.95. In the year 2004, what is the difference between the Expenses (% of total expenses) of Iran and Expenses (% of total expenses) of Lithuania?
Offer a very short reply. -22.31. In the year 2004, what is the difference between the Expenses (% of total expenses) of Iran and Expenses (% of total expenses) of St. Vincent and the Grenadines?
Offer a terse response. 18.3. In the year 2004, what is the difference between the Expenses (% of total expenses) in Lithuania and Expenses (% of total expenses) in St. Vincent and the Grenadines?
Keep it short and to the point. 40.61. In the year 2005, what is the difference between the Expenses (% of total expenses) of Cyprus and Expenses (% of total expenses) of Iran?
Ensure brevity in your answer.  1.9. In the year 2005, what is the difference between the Expenses (% of total expenses) in Cyprus and Expenses (% of total expenses) in Lithuania?
Provide a short and direct response. -23.14. In the year 2005, what is the difference between the Expenses (% of total expenses) in Cyprus and Expenses (% of total expenses) in St. Vincent and the Grenadines?
Ensure brevity in your answer.  13.57. In the year 2005, what is the difference between the Expenses (% of total expenses) of Iran and Expenses (% of total expenses) of Lithuania?
Ensure brevity in your answer.  -25.04. In the year 2005, what is the difference between the Expenses (% of total expenses) of Iran and Expenses (% of total expenses) of St. Vincent and the Grenadines?
Keep it short and to the point. 11.66. In the year 2005, what is the difference between the Expenses (% of total expenses) in Lithuania and Expenses (% of total expenses) in St. Vincent and the Grenadines?
Offer a terse response. 36.7. In the year 2006, what is the difference between the Expenses (% of total expenses) in Cyprus and Expenses (% of total expenses) in Iran?
Provide a succinct answer. 1.01. In the year 2006, what is the difference between the Expenses (% of total expenses) of Cyprus and Expenses (% of total expenses) of Lithuania?
Ensure brevity in your answer.  -25.67. In the year 2006, what is the difference between the Expenses (% of total expenses) in Cyprus and Expenses (% of total expenses) in St. Vincent and the Grenadines?
Offer a terse response. 12.69. In the year 2006, what is the difference between the Expenses (% of total expenses) of Iran and Expenses (% of total expenses) of Lithuania?
Your answer should be compact. -26.68. In the year 2006, what is the difference between the Expenses (% of total expenses) of Iran and Expenses (% of total expenses) of St. Vincent and the Grenadines?
Give a very brief answer. 11.68. In the year 2006, what is the difference between the Expenses (% of total expenses) in Lithuania and Expenses (% of total expenses) in St. Vincent and the Grenadines?
Provide a succinct answer. 38.36. In the year 2007, what is the difference between the Expenses (% of total expenses) in Cyprus and Expenses (% of total expenses) in Iran?
Provide a succinct answer. 3.54. In the year 2007, what is the difference between the Expenses (% of total expenses) of Cyprus and Expenses (% of total expenses) of Lithuania?
Give a very brief answer. -15.77. In the year 2007, what is the difference between the Expenses (% of total expenses) in Cyprus and Expenses (% of total expenses) in St. Vincent and the Grenadines?
Keep it short and to the point. 24.02. In the year 2007, what is the difference between the Expenses (% of total expenses) in Iran and Expenses (% of total expenses) in Lithuania?
Offer a terse response. -19.31. In the year 2007, what is the difference between the Expenses (% of total expenses) in Iran and Expenses (% of total expenses) in St. Vincent and the Grenadines?
Ensure brevity in your answer.  20.47. In the year 2007, what is the difference between the Expenses (% of total expenses) of Lithuania and Expenses (% of total expenses) of St. Vincent and the Grenadines?
Offer a very short reply. 39.78. In the year 2008, what is the difference between the Expenses (% of total expenses) of Cyprus and Expenses (% of total expenses) of Iran?
Ensure brevity in your answer.  -4.41. In the year 2008, what is the difference between the Expenses (% of total expenses) of Cyprus and Expenses (% of total expenses) of Lithuania?
Offer a terse response. -28.49. In the year 2008, what is the difference between the Expenses (% of total expenses) of Cyprus and Expenses (% of total expenses) of St. Vincent and the Grenadines?
Provide a short and direct response. 12.4. In the year 2008, what is the difference between the Expenses (% of total expenses) of Iran and Expenses (% of total expenses) of Lithuania?
Offer a terse response. -24.08. In the year 2008, what is the difference between the Expenses (% of total expenses) in Iran and Expenses (% of total expenses) in St. Vincent and the Grenadines?
Your answer should be compact. 16.81. In the year 2008, what is the difference between the Expenses (% of total expenses) in Lithuania and Expenses (% of total expenses) in St. Vincent and the Grenadines?
Give a very brief answer. 40.89. In the year 2009, what is the difference between the Expenses (% of total expenses) in Cyprus and Expenses (% of total expenses) in Iran?
Your answer should be compact. -1.84. In the year 2009, what is the difference between the Expenses (% of total expenses) in Cyprus and Expenses (% of total expenses) in Lithuania?
Provide a succinct answer. -32.11. In the year 2009, what is the difference between the Expenses (% of total expenses) in Cyprus and Expenses (% of total expenses) in St. Vincent and the Grenadines?
Make the answer very short. 6.79. In the year 2009, what is the difference between the Expenses (% of total expenses) in Iran and Expenses (% of total expenses) in Lithuania?
Provide a succinct answer. -30.28. In the year 2009, what is the difference between the Expenses (% of total expenses) of Iran and Expenses (% of total expenses) of St. Vincent and the Grenadines?
Offer a very short reply. 8.63. In the year 2009, what is the difference between the Expenses (% of total expenses) in Lithuania and Expenses (% of total expenses) in St. Vincent and the Grenadines?
Provide a succinct answer. 38.9. What is the ratio of the Expenses (% of total expenses) of Cyprus in 2003 to that in 2004?
Give a very brief answer. 0.91. What is the ratio of the Expenses (% of total expenses) in Iran in 2003 to that in 2004?
Your answer should be compact. 0.98. What is the ratio of the Expenses (% of total expenses) of Lithuania in 2003 to that in 2004?
Ensure brevity in your answer.  0.97. What is the ratio of the Expenses (% of total expenses) in St. Vincent and the Grenadines in 2003 to that in 2004?
Offer a very short reply. 1.02. What is the ratio of the Expenses (% of total expenses) of Cyprus in 2003 to that in 2005?
Keep it short and to the point. 0.91. What is the ratio of the Expenses (% of total expenses) in Iran in 2003 to that in 2005?
Keep it short and to the point. 1.16. What is the ratio of the Expenses (% of total expenses) in Lithuania in 2003 to that in 2005?
Your response must be concise. 1.02. What is the ratio of the Expenses (% of total expenses) of St. Vincent and the Grenadines in 2003 to that in 2005?
Offer a very short reply. 0.96. What is the ratio of the Expenses (% of total expenses) of Cyprus in 2003 to that in 2006?
Offer a very short reply. 0.95. What is the ratio of the Expenses (% of total expenses) of Iran in 2003 to that in 2006?
Keep it short and to the point. 1.17. What is the ratio of the Expenses (% of total expenses) in St. Vincent and the Grenadines in 2003 to that in 2006?
Make the answer very short. 0.97. What is the ratio of the Expenses (% of total expenses) in Cyprus in 2003 to that in 2007?
Provide a short and direct response. 0.68. What is the ratio of the Expenses (% of total expenses) of Iran in 2003 to that in 2007?
Provide a short and direct response. 0.89. What is the ratio of the Expenses (% of total expenses) of Lithuania in 2003 to that in 2007?
Keep it short and to the point. 0.96. What is the ratio of the Expenses (% of total expenses) of St. Vincent and the Grenadines in 2003 to that in 2007?
Provide a succinct answer. 0.95. What is the ratio of the Expenses (% of total expenses) of Cyprus in 2003 to that in 2008?
Your response must be concise. 0.9. What is the ratio of the Expenses (% of total expenses) in Iran in 2003 to that in 2008?
Offer a terse response. 0.94. What is the ratio of the Expenses (% of total expenses) in Lithuania in 2003 to that in 2008?
Your answer should be very brief. 0.92. What is the ratio of the Expenses (% of total expenses) of St. Vincent and the Grenadines in 2003 to that in 2008?
Provide a short and direct response. 0.87. What is the ratio of the Expenses (% of total expenses) in Cyprus in 2003 to that in 2009?
Your answer should be very brief. 0.89. What is the ratio of the Expenses (% of total expenses) of Iran in 2003 to that in 2009?
Your answer should be very brief. 1.01. What is the ratio of the Expenses (% of total expenses) of Lithuania in 2003 to that in 2009?
Provide a short and direct response. 0.87. What is the ratio of the Expenses (% of total expenses) in St. Vincent and the Grenadines in 2003 to that in 2009?
Keep it short and to the point. 0.68. What is the ratio of the Expenses (% of total expenses) in Cyprus in 2004 to that in 2005?
Offer a terse response. 1.01. What is the ratio of the Expenses (% of total expenses) of Iran in 2004 to that in 2005?
Keep it short and to the point. 1.18. What is the ratio of the Expenses (% of total expenses) in Lithuania in 2004 to that in 2005?
Offer a terse response. 1.05. What is the ratio of the Expenses (% of total expenses) in St. Vincent and the Grenadines in 2004 to that in 2005?
Keep it short and to the point. 0.93. What is the ratio of the Expenses (% of total expenses) in Cyprus in 2004 to that in 2006?
Provide a short and direct response. 1.04. What is the ratio of the Expenses (% of total expenses) of Iran in 2004 to that in 2006?
Provide a succinct answer. 1.19. What is the ratio of the Expenses (% of total expenses) of Lithuania in 2004 to that in 2006?
Provide a short and direct response. 1.02. What is the ratio of the Expenses (% of total expenses) of St. Vincent and the Grenadines in 2004 to that in 2006?
Ensure brevity in your answer.  0.95. What is the ratio of the Expenses (% of total expenses) in Cyprus in 2004 to that in 2007?
Provide a succinct answer. 0.75. What is the ratio of the Expenses (% of total expenses) of Iran in 2004 to that in 2007?
Your answer should be very brief. 0.91. What is the ratio of the Expenses (% of total expenses) in Lithuania in 2004 to that in 2007?
Your answer should be compact. 0.99. What is the ratio of the Expenses (% of total expenses) in St. Vincent and the Grenadines in 2004 to that in 2007?
Your response must be concise. 0.92. What is the ratio of the Expenses (% of total expenses) of Cyprus in 2004 to that in 2008?
Ensure brevity in your answer.  0.99. What is the ratio of the Expenses (% of total expenses) in Iran in 2004 to that in 2008?
Ensure brevity in your answer.  0.96. What is the ratio of the Expenses (% of total expenses) of Lithuania in 2004 to that in 2008?
Offer a terse response. 0.95. What is the ratio of the Expenses (% of total expenses) in St. Vincent and the Grenadines in 2004 to that in 2008?
Keep it short and to the point. 0.85. What is the ratio of the Expenses (% of total expenses) in Cyprus in 2004 to that in 2009?
Offer a very short reply. 0.98. What is the ratio of the Expenses (% of total expenses) of Iran in 2004 to that in 2009?
Make the answer very short. 1.03. What is the ratio of the Expenses (% of total expenses) of Lithuania in 2004 to that in 2009?
Give a very brief answer. 0.89. What is the ratio of the Expenses (% of total expenses) of St. Vincent and the Grenadines in 2004 to that in 2009?
Ensure brevity in your answer.  0.66. What is the ratio of the Expenses (% of total expenses) in Cyprus in 2005 to that in 2006?
Your answer should be compact. 1.04. What is the ratio of the Expenses (% of total expenses) in Iran in 2005 to that in 2006?
Make the answer very short. 1.01. What is the ratio of the Expenses (% of total expenses) in Lithuania in 2005 to that in 2006?
Provide a short and direct response. 0.97. What is the ratio of the Expenses (% of total expenses) of St. Vincent and the Grenadines in 2005 to that in 2006?
Provide a succinct answer. 1.01. What is the ratio of the Expenses (% of total expenses) of Cyprus in 2005 to that in 2007?
Your response must be concise. 0.75. What is the ratio of the Expenses (% of total expenses) of Iran in 2005 to that in 2007?
Ensure brevity in your answer.  0.77. What is the ratio of the Expenses (% of total expenses) of Lithuania in 2005 to that in 2007?
Provide a succinct answer. 0.94. What is the ratio of the Expenses (% of total expenses) of St. Vincent and the Grenadines in 2005 to that in 2007?
Your answer should be compact. 0.99. What is the ratio of the Expenses (% of total expenses) in Cyprus in 2005 to that in 2008?
Ensure brevity in your answer.  0.98. What is the ratio of the Expenses (% of total expenses) in Iran in 2005 to that in 2008?
Ensure brevity in your answer.  0.81. What is the ratio of the Expenses (% of total expenses) of Lithuania in 2005 to that in 2008?
Make the answer very short. 0.9. What is the ratio of the Expenses (% of total expenses) in St. Vincent and the Grenadines in 2005 to that in 2008?
Ensure brevity in your answer.  0.91. What is the ratio of the Expenses (% of total expenses) in Cyprus in 2005 to that in 2009?
Your answer should be compact. 0.98. What is the ratio of the Expenses (% of total expenses) of Iran in 2005 to that in 2009?
Give a very brief answer. 0.87. What is the ratio of the Expenses (% of total expenses) of Lithuania in 2005 to that in 2009?
Provide a succinct answer. 0.85. What is the ratio of the Expenses (% of total expenses) in St. Vincent and the Grenadines in 2005 to that in 2009?
Offer a terse response. 0.71. What is the ratio of the Expenses (% of total expenses) in Cyprus in 2006 to that in 2007?
Provide a short and direct response. 0.72. What is the ratio of the Expenses (% of total expenses) of Iran in 2006 to that in 2007?
Provide a succinct answer. 0.76. What is the ratio of the Expenses (% of total expenses) in St. Vincent and the Grenadines in 2006 to that in 2007?
Offer a very short reply. 0.98. What is the ratio of the Expenses (% of total expenses) in Cyprus in 2006 to that in 2008?
Make the answer very short. 0.95. What is the ratio of the Expenses (% of total expenses) in Iran in 2006 to that in 2008?
Make the answer very short. 0.81. What is the ratio of the Expenses (% of total expenses) of Lithuania in 2006 to that in 2008?
Your answer should be very brief. 0.93. What is the ratio of the Expenses (% of total expenses) in St. Vincent and the Grenadines in 2006 to that in 2008?
Keep it short and to the point. 0.9. What is the ratio of the Expenses (% of total expenses) in Cyprus in 2006 to that in 2009?
Give a very brief answer. 0.95. What is the ratio of the Expenses (% of total expenses) in Iran in 2006 to that in 2009?
Your answer should be compact. 0.87. What is the ratio of the Expenses (% of total expenses) of Lithuania in 2006 to that in 2009?
Give a very brief answer. 0.87. What is the ratio of the Expenses (% of total expenses) of St. Vincent and the Grenadines in 2006 to that in 2009?
Your answer should be very brief. 0.7. What is the ratio of the Expenses (% of total expenses) of Cyprus in 2007 to that in 2008?
Give a very brief answer. 1.31. What is the ratio of the Expenses (% of total expenses) of Iran in 2007 to that in 2008?
Your response must be concise. 1.06. What is the ratio of the Expenses (% of total expenses) of Lithuania in 2007 to that in 2008?
Your response must be concise. 0.96. What is the ratio of the Expenses (% of total expenses) of St. Vincent and the Grenadines in 2007 to that in 2008?
Offer a very short reply. 0.92. What is the ratio of the Expenses (% of total expenses) of Cyprus in 2007 to that in 2009?
Make the answer very short. 1.31. What is the ratio of the Expenses (% of total expenses) in Iran in 2007 to that in 2009?
Ensure brevity in your answer.  1.13. What is the ratio of the Expenses (% of total expenses) of Lithuania in 2007 to that in 2009?
Your answer should be very brief. 0.9. What is the ratio of the Expenses (% of total expenses) in St. Vincent and the Grenadines in 2007 to that in 2009?
Your response must be concise. 0.72. What is the ratio of the Expenses (% of total expenses) of Iran in 2008 to that in 2009?
Offer a terse response. 1.07. What is the ratio of the Expenses (% of total expenses) in Lithuania in 2008 to that in 2009?
Ensure brevity in your answer.  0.94. What is the ratio of the Expenses (% of total expenses) in St. Vincent and the Grenadines in 2008 to that in 2009?
Ensure brevity in your answer.  0.78. What is the difference between the highest and the second highest Expenses (% of total expenses) in Cyprus?
Give a very brief answer. 9.99. What is the difference between the highest and the second highest Expenses (% of total expenses) of Iran?
Give a very brief answer. 2.1. What is the difference between the highest and the second highest Expenses (% of total expenses) of Lithuania?
Your response must be concise. 3.69. What is the difference between the highest and the second highest Expenses (% of total expenses) of St. Vincent and the Grenadines?
Provide a succinct answer. 5.68. What is the difference between the highest and the lowest Expenses (% of total expenses) in Cyprus?
Your answer should be compact. 13.41. What is the difference between the highest and the lowest Expenses (% of total expenses) in Iran?
Offer a very short reply. 9.23. What is the difference between the highest and the lowest Expenses (% of total expenses) in Lithuania?
Offer a very short reply. 9.64. What is the difference between the highest and the lowest Expenses (% of total expenses) in St. Vincent and the Grenadines?
Ensure brevity in your answer.  8.65. 